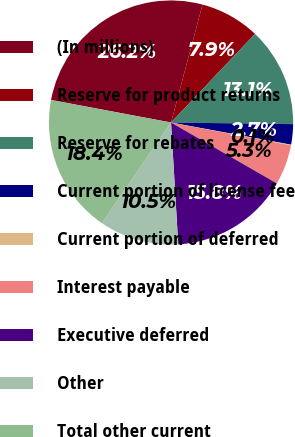<chart> <loc_0><loc_0><loc_500><loc_500><pie_chart><fcel>(In millions)<fcel>Reserve for product returns<fcel>Reserve for rebates<fcel>Current portion of license fee<fcel>Current portion of deferred<fcel>Interest payable<fcel>Executive deferred<fcel>Other<fcel>Total other current<nl><fcel>26.19%<fcel>7.92%<fcel>13.14%<fcel>2.7%<fcel>0.09%<fcel>5.31%<fcel>15.75%<fcel>10.53%<fcel>18.36%<nl></chart> 